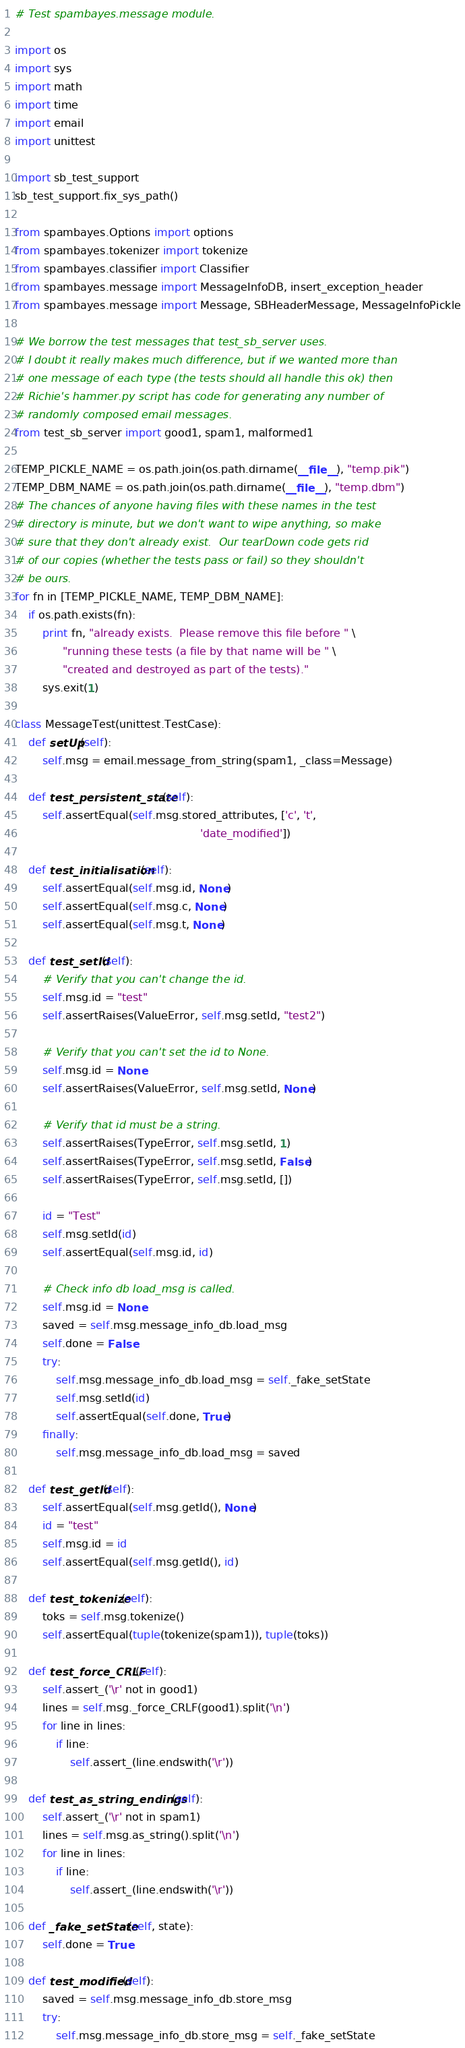Convert code to text. <code><loc_0><loc_0><loc_500><loc_500><_Python_># Test spambayes.message module.

import os
import sys
import math
import time
import email
import unittest

import sb_test_support
sb_test_support.fix_sys_path()

from spambayes.Options import options
from spambayes.tokenizer import tokenize
from spambayes.classifier import Classifier
from spambayes.message import MessageInfoDB, insert_exception_header
from spambayes.message import Message, SBHeaderMessage, MessageInfoPickle

# We borrow the test messages that test_sb_server uses.
# I doubt it really makes much difference, but if we wanted more than
# one message of each type (the tests should all handle this ok) then
# Richie's hammer.py script has code for generating any number of
# randomly composed email messages.
from test_sb_server import good1, spam1, malformed1

TEMP_PICKLE_NAME = os.path.join(os.path.dirname(__file__), "temp.pik")
TEMP_DBM_NAME = os.path.join(os.path.dirname(__file__), "temp.dbm")
# The chances of anyone having files with these names in the test
# directory is minute, but we don't want to wipe anything, so make
# sure that they don't already exist.  Our tearDown code gets rid
# of our copies (whether the tests pass or fail) so they shouldn't
# be ours.
for fn in [TEMP_PICKLE_NAME, TEMP_DBM_NAME]:
    if os.path.exists(fn):
        print fn, "already exists.  Please remove this file before " \
              "running these tests (a file by that name will be " \
              "created and destroyed as part of the tests)."
        sys.exit(1)

class MessageTest(unittest.TestCase):
    def setUp(self):
        self.msg = email.message_from_string(spam1, _class=Message)

    def test_persistent_state(self):
        self.assertEqual(self.msg.stored_attributes, ['c', 't',
                                                      'date_modified'])

    def test_initialisation(self):
        self.assertEqual(self.msg.id, None)
        self.assertEqual(self.msg.c, None)
        self.assertEqual(self.msg.t, None)

    def test_setId(self):
        # Verify that you can't change the id.
        self.msg.id = "test"
        self.assertRaises(ValueError, self.msg.setId, "test2")

        # Verify that you can't set the id to None.
        self.msg.id = None
        self.assertRaises(ValueError, self.msg.setId, None)

        # Verify that id must be a string.
        self.assertRaises(TypeError, self.msg.setId, 1)
        self.assertRaises(TypeError, self.msg.setId, False)
        self.assertRaises(TypeError, self.msg.setId, [])

        id = "Test"
        self.msg.setId(id)
        self.assertEqual(self.msg.id, id)

        # Check info db load_msg is called.
        self.msg.id = None
        saved = self.msg.message_info_db.load_msg
        self.done = False
        try:
            self.msg.message_info_db.load_msg = self._fake_setState
            self.msg.setId(id)
            self.assertEqual(self.done, True)
        finally:
            self.msg.message_info_db.load_msg = saved

    def test_getId(self):
        self.assertEqual(self.msg.getId(), None)
        id = "test"
        self.msg.id = id
        self.assertEqual(self.msg.getId(), id)

    def test_tokenize(self):
        toks = self.msg.tokenize()
        self.assertEqual(tuple(tokenize(spam1)), tuple(toks))

    def test_force_CRLF(self):
        self.assert_('\r' not in good1)
        lines = self.msg._force_CRLF(good1).split('\n')
        for line in lines:
            if line:
                self.assert_(line.endswith('\r'))

    def test_as_string_endings(self):
        self.assert_('\r' not in spam1)
        lines = self.msg.as_string().split('\n')
        for line in lines:
            if line:
                self.assert_(line.endswith('\r'))

    def _fake_setState(self, state):
        self.done = True
        
    def test_modified(self):
        saved = self.msg.message_info_db.store_msg
        try:
            self.msg.message_info_db.store_msg = self._fake_setState</code> 